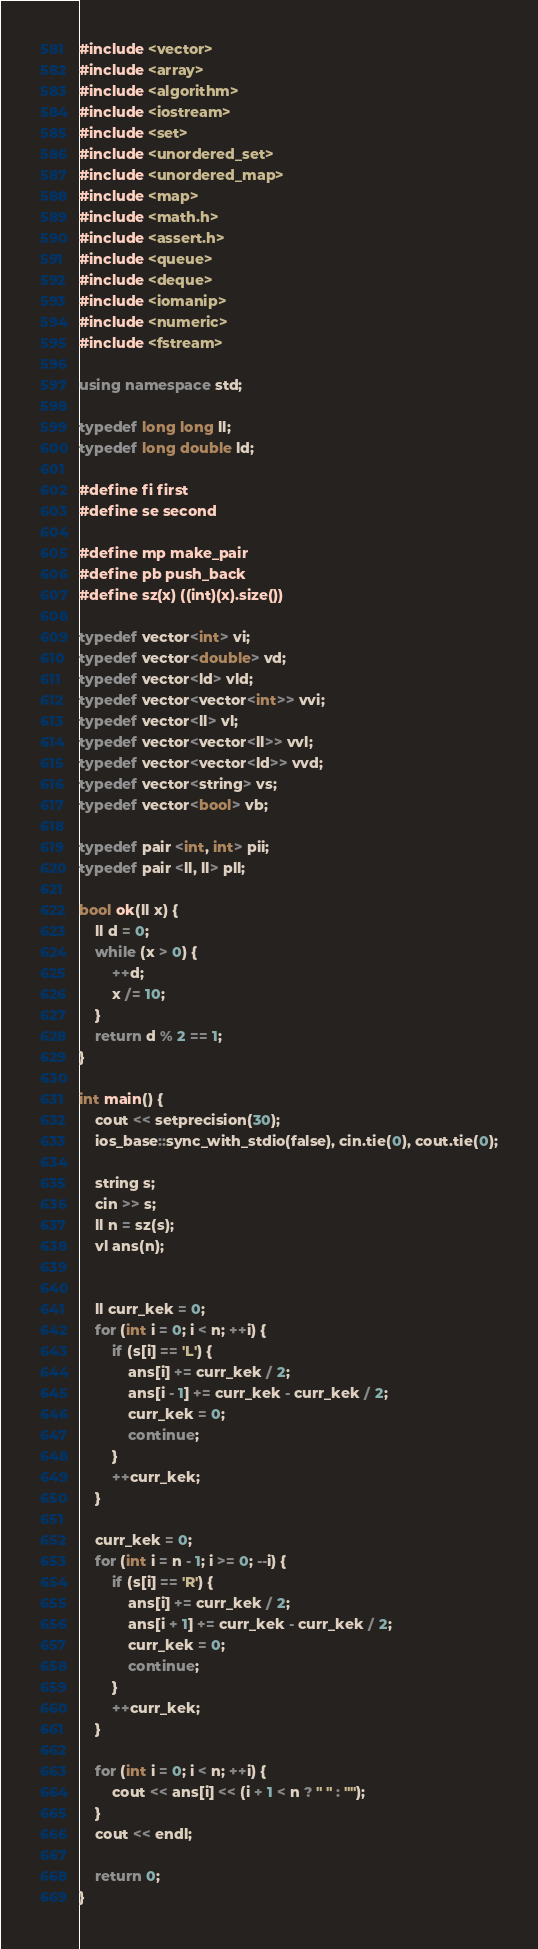<code> <loc_0><loc_0><loc_500><loc_500><_C++_>#include <vector>
#include <array>
#include <algorithm>
#include <iostream>
#include <set>
#include <unordered_set>
#include <unordered_map>
#include <map>
#include <math.h>
#include <assert.h>
#include <queue>
#include <deque>
#include <iomanip>
#include <numeric>
#include <fstream>

using namespace std;

typedef long long ll;
typedef long double ld;

#define fi first
#define se second

#define mp make_pair
#define pb push_back
#define sz(x) ((int)(x).size())

typedef vector<int> vi;
typedef vector<double> vd;
typedef vector<ld> vld;
typedef vector<vector<int>> vvi;
typedef vector<ll> vl;
typedef vector<vector<ll>> vvl;
typedef vector<vector<ld>> vvd;
typedef vector<string> vs;
typedef vector<bool> vb;

typedef pair <int, int> pii;
typedef pair <ll, ll> pll;

bool ok(ll x) {
    ll d = 0;
    while (x > 0) {
        ++d;
        x /= 10;
    }
    return d % 2 == 1;
}

int main() {
    cout << setprecision(30);
    ios_base::sync_with_stdio(false), cin.tie(0), cout.tie(0);

    string s;
    cin >> s;
    ll n = sz(s);
    vl ans(n);


    ll curr_kek = 0;
    for (int i = 0; i < n; ++i) {
        if (s[i] == 'L') {
            ans[i] += curr_kek / 2;
            ans[i - 1] += curr_kek - curr_kek / 2;
            curr_kek = 0;
            continue;
        }
        ++curr_kek;
    }

    curr_kek = 0;
    for (int i = n - 1; i >= 0; --i) {
        if (s[i] == 'R') {
            ans[i] += curr_kek / 2;
            ans[i + 1] += curr_kek - curr_kek / 2;
            curr_kek = 0;
            continue;
        }
        ++curr_kek;
    }

    for (int i = 0; i < n; ++i) {
        cout << ans[i] << (i + 1 < n ? " " : "");
    }
    cout << endl;

    return 0;
}
</code> 